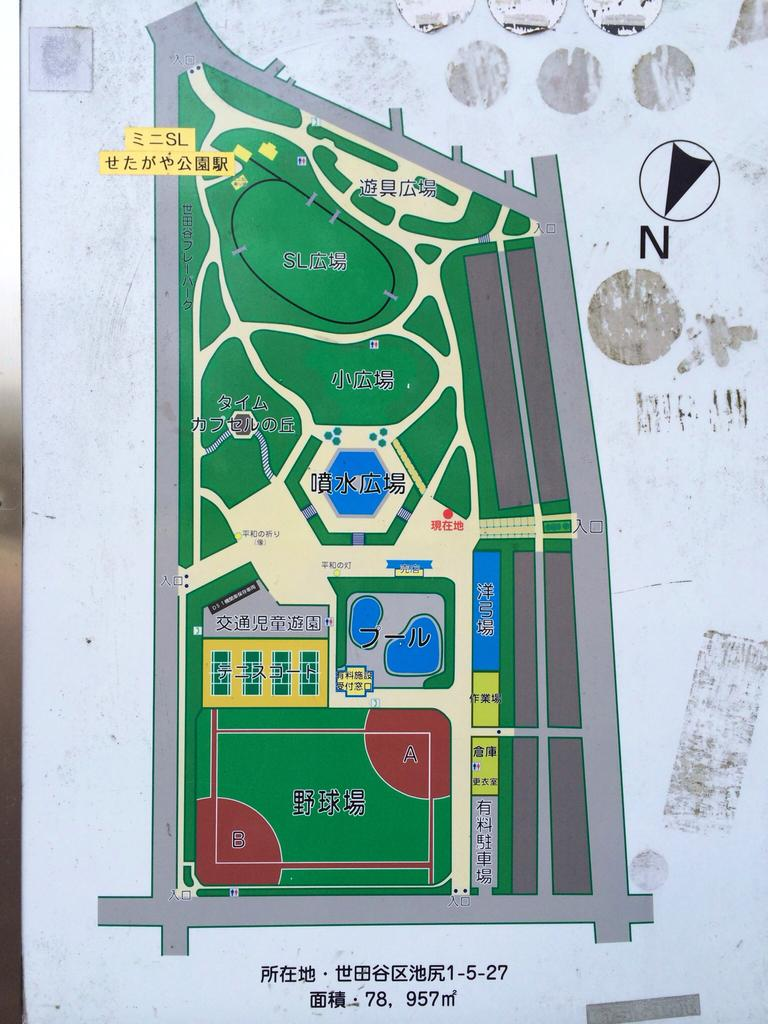What is the main subject of the image? The main subject of the image is a map. What else can be seen in the image besides the map? There is information on a whiteboard in the image. Where is the cemetery located in the image? There is no cemetery present in the image; it only features a map and information on a whiteboard. 